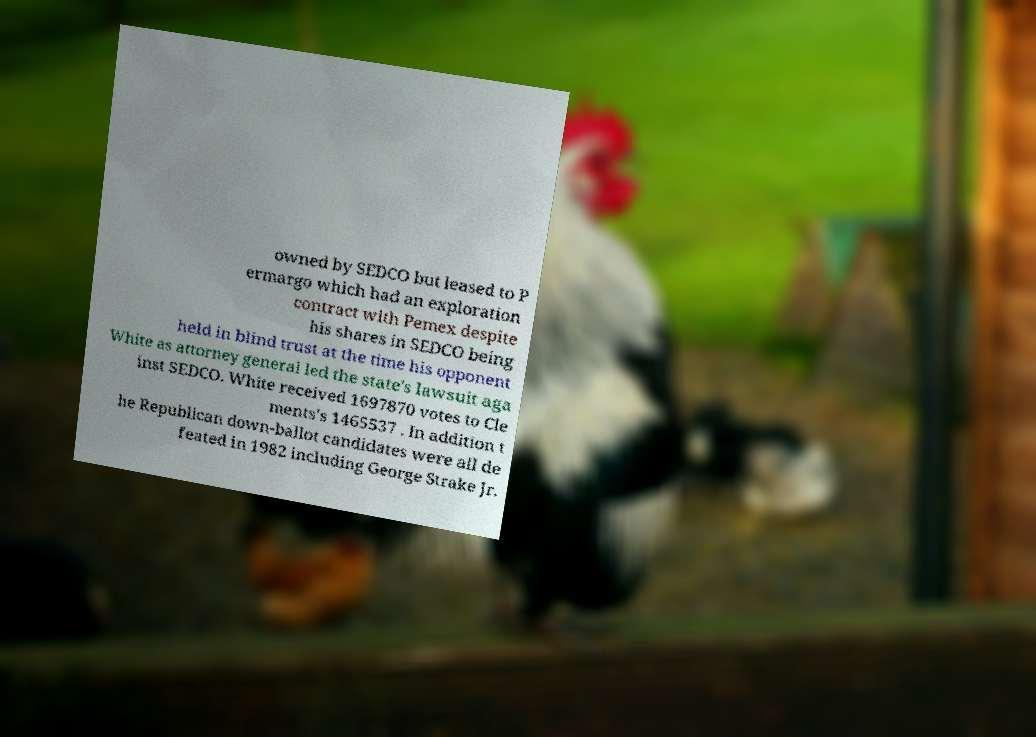What messages or text are displayed in this image? I need them in a readable, typed format. owned by SEDCO but leased to P ermargo which had an exploration contract with Pemex despite his shares in SEDCO being held in blind trust at the time his opponent White as attorney general led the state's lawsuit aga inst SEDCO. White received 1697870 votes to Cle ments's 1465537 . In addition t he Republican down-ballot candidates were all de feated in 1982 including George Strake Jr. 